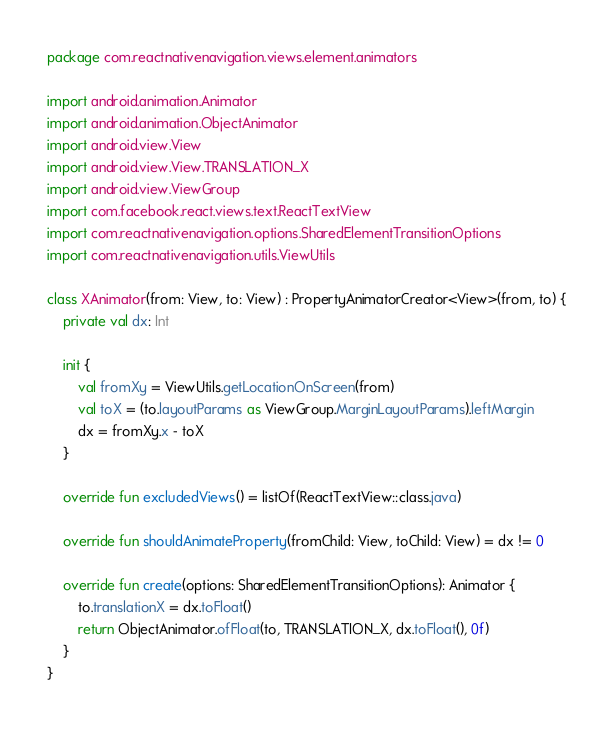Convert code to text. <code><loc_0><loc_0><loc_500><loc_500><_Kotlin_>package com.reactnativenavigation.views.element.animators

import android.animation.Animator
import android.animation.ObjectAnimator
import android.view.View
import android.view.View.TRANSLATION_X
import android.view.ViewGroup
import com.facebook.react.views.text.ReactTextView
import com.reactnativenavigation.options.SharedElementTransitionOptions
import com.reactnativenavigation.utils.ViewUtils

class XAnimator(from: View, to: View) : PropertyAnimatorCreator<View>(from, to) {
    private val dx: Int

    init {
        val fromXy = ViewUtils.getLocationOnScreen(from)
        val toX = (to.layoutParams as ViewGroup.MarginLayoutParams).leftMargin
        dx = fromXy.x - toX
    }

    override fun excludedViews() = listOf(ReactTextView::class.java)

    override fun shouldAnimateProperty(fromChild: View, toChild: View) = dx != 0

    override fun create(options: SharedElementTransitionOptions): Animator {
        to.translationX = dx.toFloat()
        return ObjectAnimator.ofFloat(to, TRANSLATION_X, dx.toFloat(), 0f)
    }
}</code> 